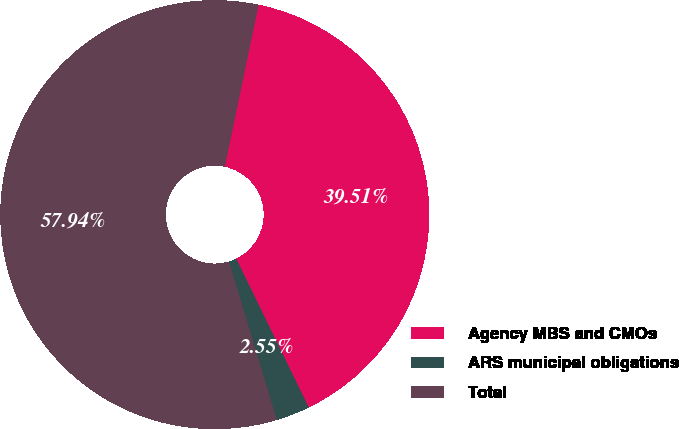Convert chart. <chart><loc_0><loc_0><loc_500><loc_500><pie_chart><fcel>Agency MBS and CMOs<fcel>ARS municipal obligations<fcel>Total<nl><fcel>39.51%<fcel>2.55%<fcel>57.94%<nl></chart> 